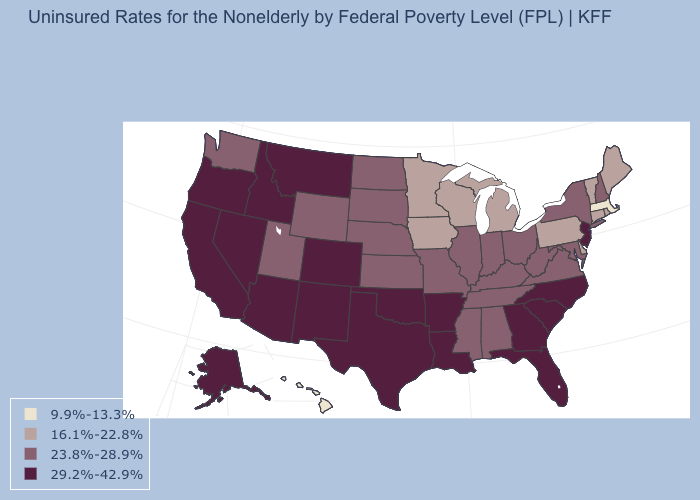Name the states that have a value in the range 16.1%-22.8%?
Quick response, please. Connecticut, Delaware, Iowa, Maine, Michigan, Minnesota, Pennsylvania, Rhode Island, Vermont, Wisconsin. Which states have the highest value in the USA?
Write a very short answer. Alaska, Arizona, Arkansas, California, Colorado, Florida, Georgia, Idaho, Louisiana, Montana, Nevada, New Jersey, New Mexico, North Carolina, Oklahoma, Oregon, South Carolina, Texas. How many symbols are there in the legend?
Keep it brief. 4. Name the states that have a value in the range 9.9%-13.3%?
Answer briefly. Hawaii, Massachusetts. Name the states that have a value in the range 23.8%-28.9%?
Answer briefly. Alabama, Illinois, Indiana, Kansas, Kentucky, Maryland, Mississippi, Missouri, Nebraska, New Hampshire, New York, North Dakota, Ohio, South Dakota, Tennessee, Utah, Virginia, Washington, West Virginia, Wyoming. What is the value of Vermont?
Keep it brief. 16.1%-22.8%. Does the map have missing data?
Give a very brief answer. No. What is the highest value in the Northeast ?
Be succinct. 29.2%-42.9%. What is the value of Arizona?
Be succinct. 29.2%-42.9%. Among the states that border Georgia , does Alabama have the lowest value?
Short answer required. Yes. How many symbols are there in the legend?
Answer briefly. 4. What is the value of West Virginia?
Give a very brief answer. 23.8%-28.9%. What is the value of Connecticut?
Answer briefly. 16.1%-22.8%. Name the states that have a value in the range 9.9%-13.3%?
Short answer required. Hawaii, Massachusetts. Name the states that have a value in the range 9.9%-13.3%?
Short answer required. Hawaii, Massachusetts. 